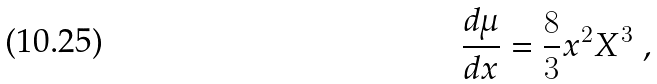Convert formula to latex. <formula><loc_0><loc_0><loc_500><loc_500>\frac { d \mu } { d x } = \frac { 8 } { 3 } x ^ { 2 } X ^ { 3 } \ ,</formula> 